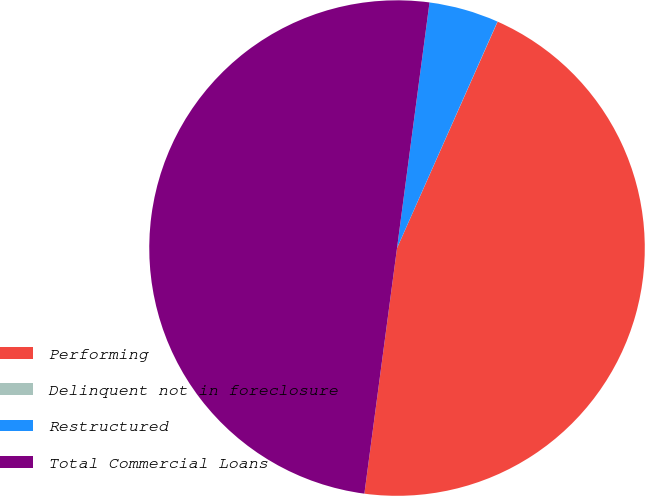Convert chart to OTSL. <chart><loc_0><loc_0><loc_500><loc_500><pie_chart><fcel>Performing<fcel>Delinquent not in foreclosure<fcel>Restructured<fcel>Total Commercial Loans<nl><fcel>45.45%<fcel>0.01%<fcel>4.55%<fcel>49.99%<nl></chart> 